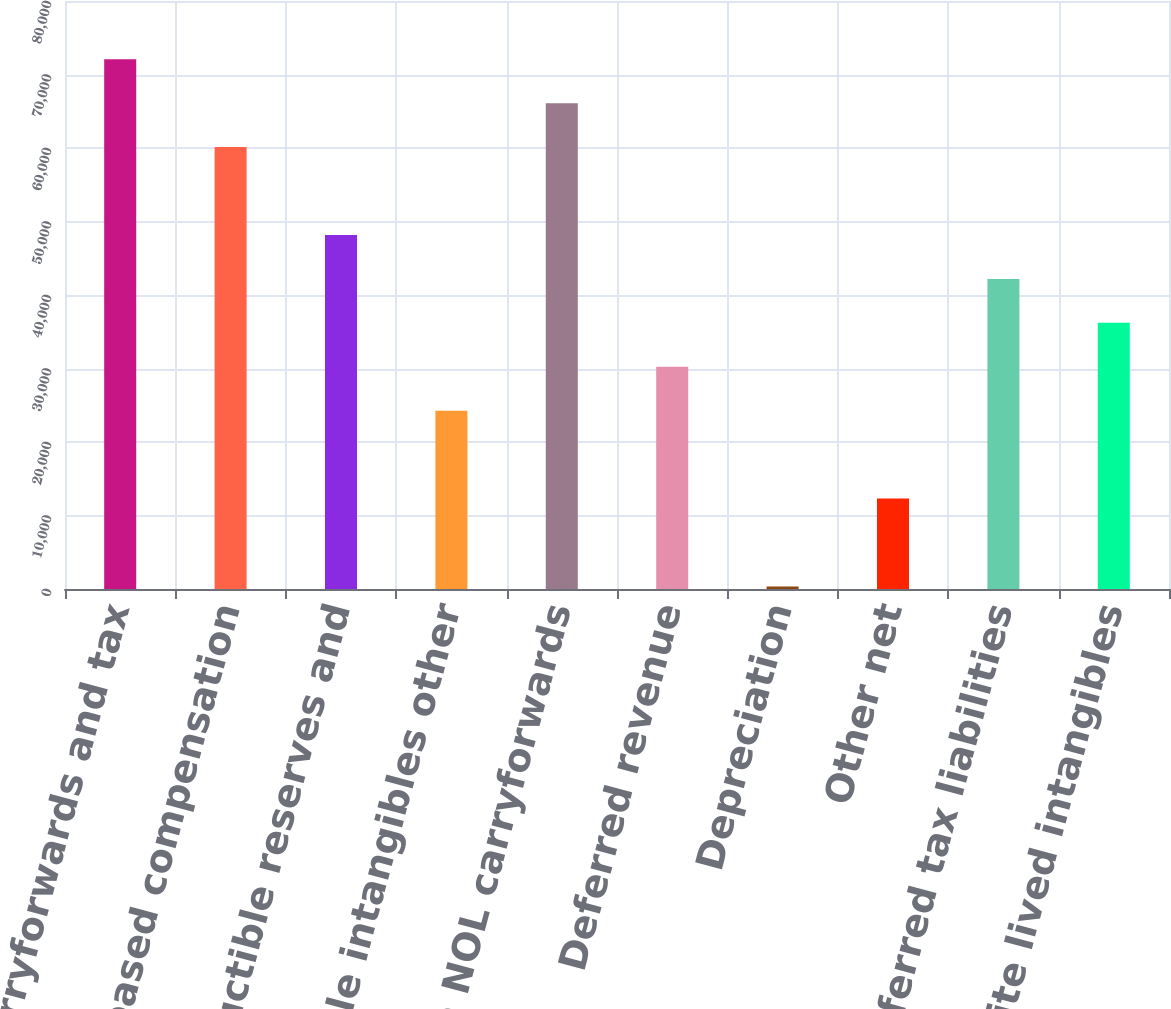<chart> <loc_0><loc_0><loc_500><loc_500><bar_chart><fcel>NOL carryforwards and tax<fcel>Stock-based compensation<fcel>Nondeductible reserves and<fcel>Amortizable intangibles other<fcel>Foreign NOL carryforwards<fcel>Deferred revenue<fcel>Depreciation<fcel>Other net<fcel>Deferred tax liabilities<fcel>Indefinite lived intangibles<nl><fcel>72073.4<fcel>60120<fcel>48166.6<fcel>24259.8<fcel>66096.7<fcel>30236.5<fcel>353<fcel>12306.4<fcel>42189.9<fcel>36213.2<nl></chart> 